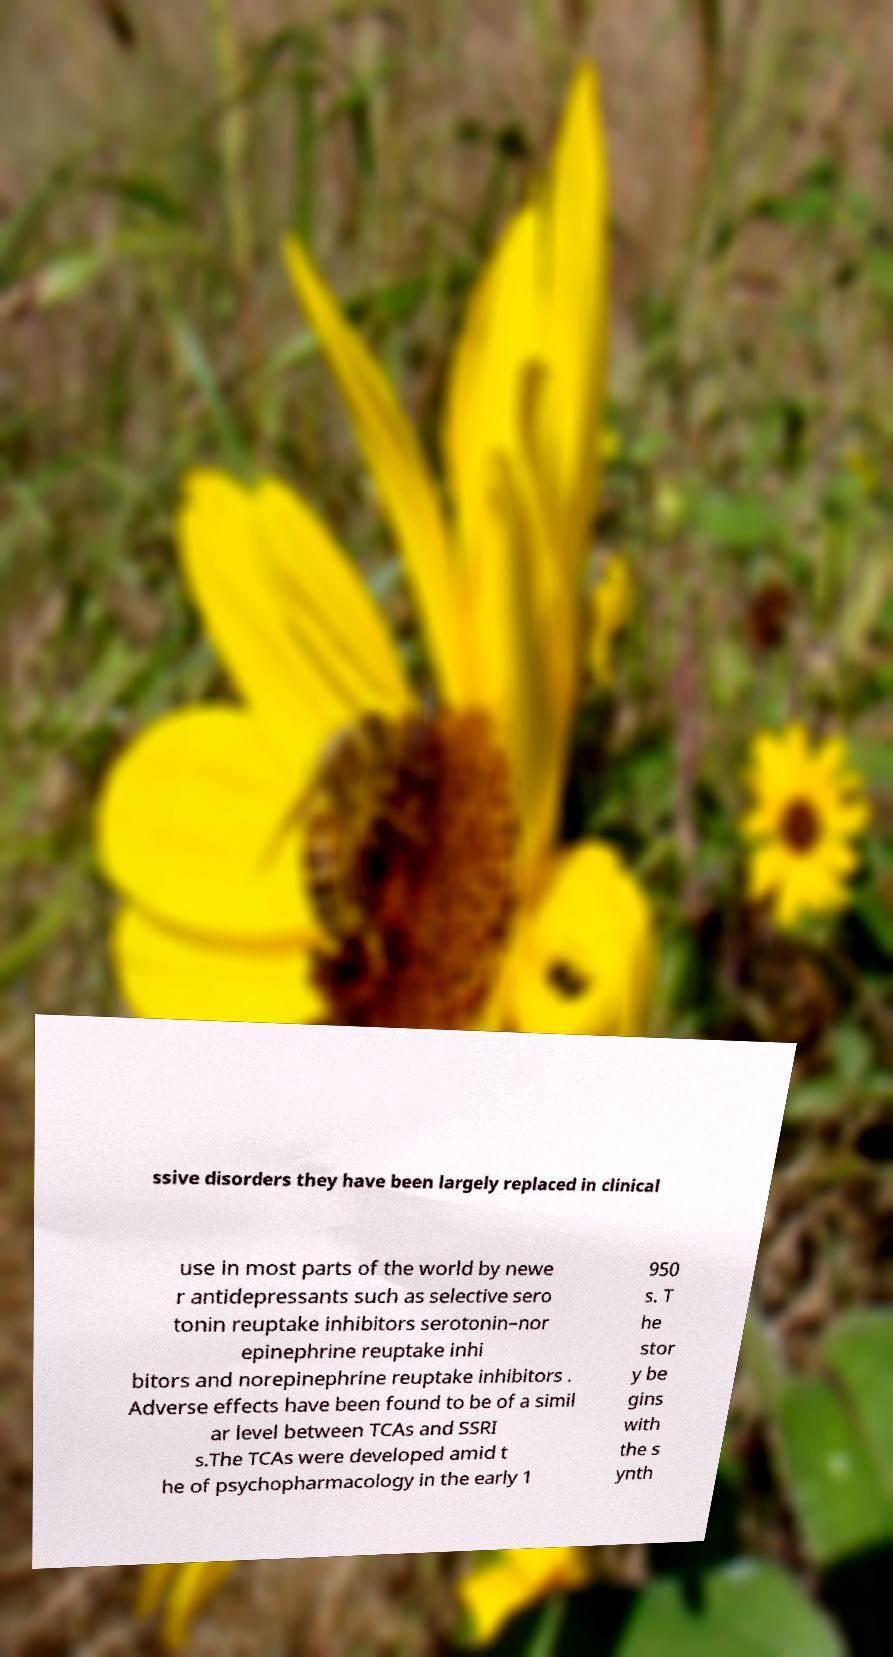What messages or text are displayed in this image? I need them in a readable, typed format. ssive disorders they have been largely replaced in clinical use in most parts of the world by newe r antidepressants such as selective sero tonin reuptake inhibitors serotonin–nor epinephrine reuptake inhi bitors and norepinephrine reuptake inhibitors . Adverse effects have been found to be of a simil ar level between TCAs and SSRI s.The TCAs were developed amid t he of psychopharmacology in the early 1 950 s. T he stor y be gins with the s ynth 